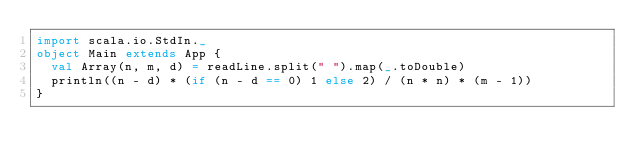Convert code to text. <code><loc_0><loc_0><loc_500><loc_500><_Scala_>import scala.io.StdIn._
object Main extends App {
  val Array(n, m, d) = readLine.split(" ").map(_.toDouble)
  println((n - d) * (if (n - d == 0) 1 else 2) / (n * n) * (m - 1))
}</code> 